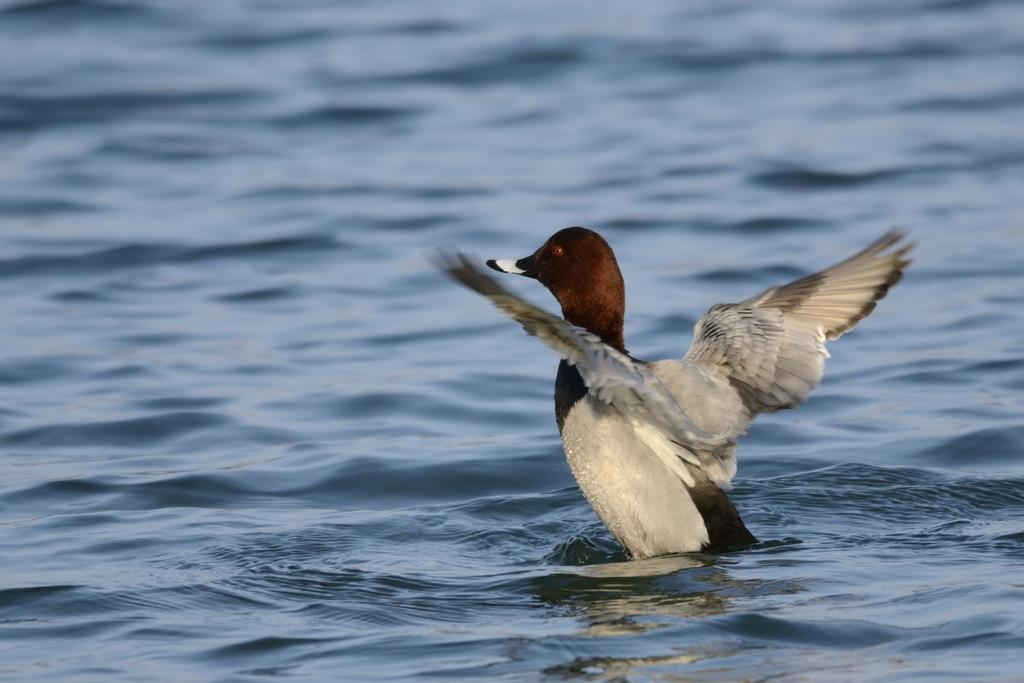What type of animal can be seen in the image? There is a bird in the image. Where is the bird located in the image? The bird is on the right side of the image. What can be seen in the background of the image? There is water visible in the image. What type of crate can be seen in the image? There is no crate present in the image. Can you describe how the bird is touching the water in the image? The bird is not touching the water in the image; it is on the right side of the image. 